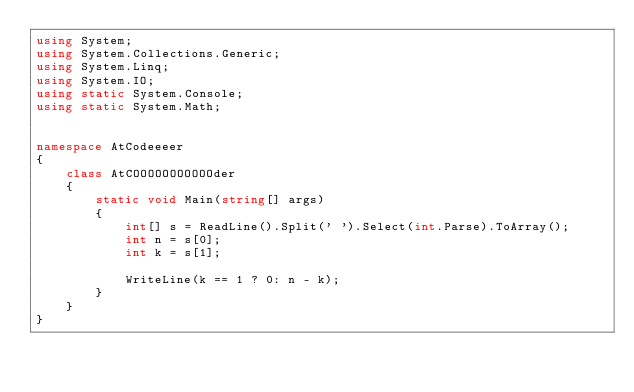Convert code to text. <code><loc_0><loc_0><loc_500><loc_500><_C#_>using System;
using System.Collections.Generic;
using System.Linq;
using System.IO;
using static System.Console;
using static System.Math;


namespace AtCodeeeer
{
    class AtCOOOOOOOOOOOder
    {
        static void Main(string[] args)
        {
            int[] s = ReadLine().Split(' ').Select(int.Parse).ToArray();
            int n = s[0];
            int k = s[1];

            WriteLine(k == 1 ? 0: n - k);
        }
    }
}
</code> 